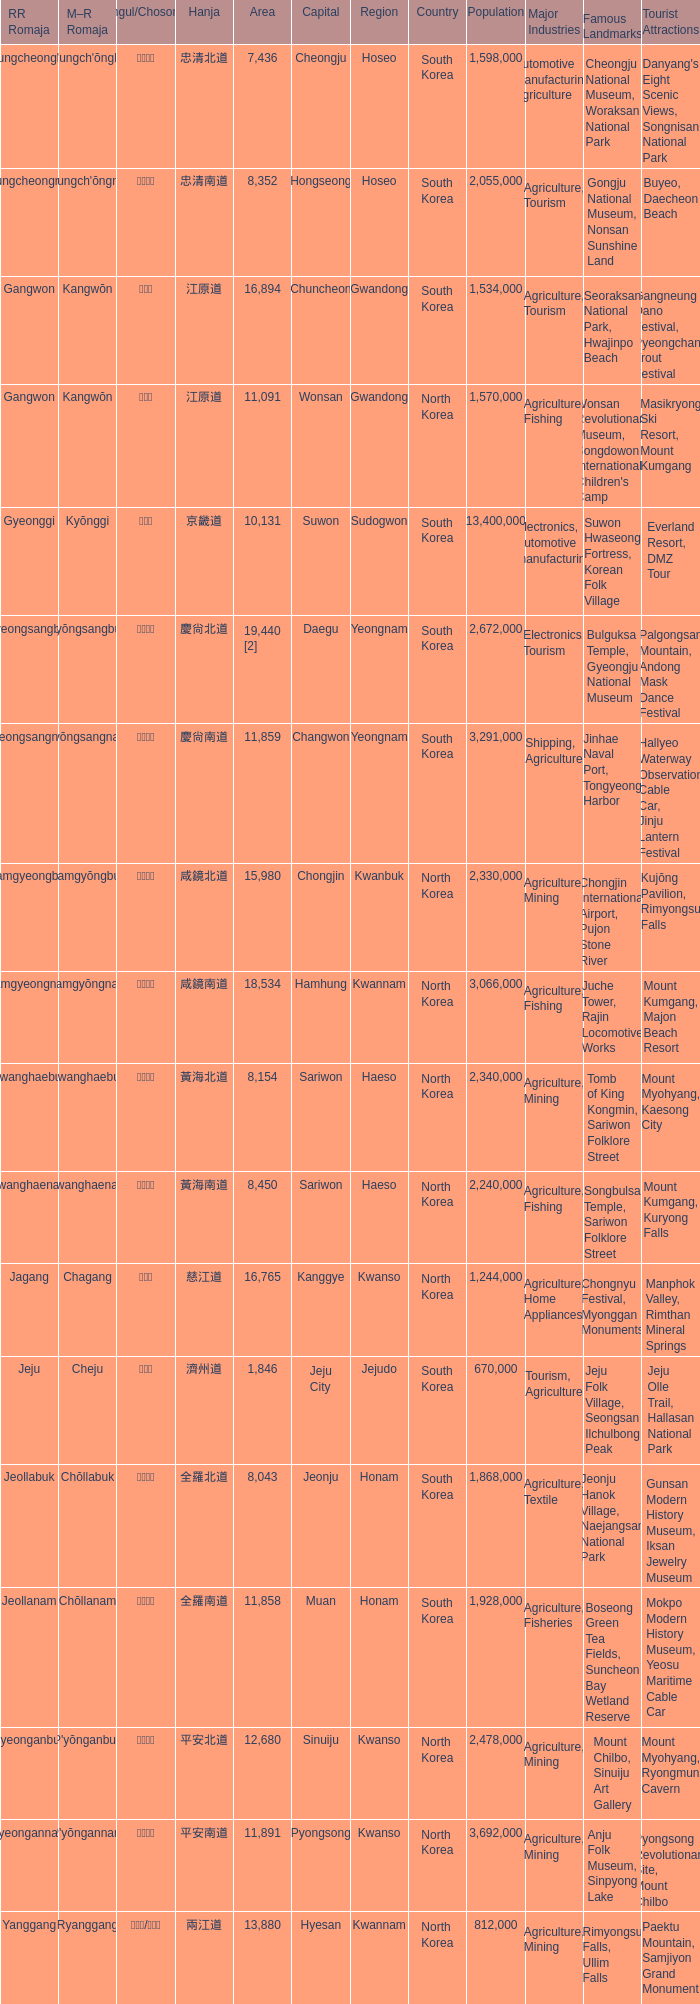Which country has a city with a Hanja of 平安北道? North Korea. 